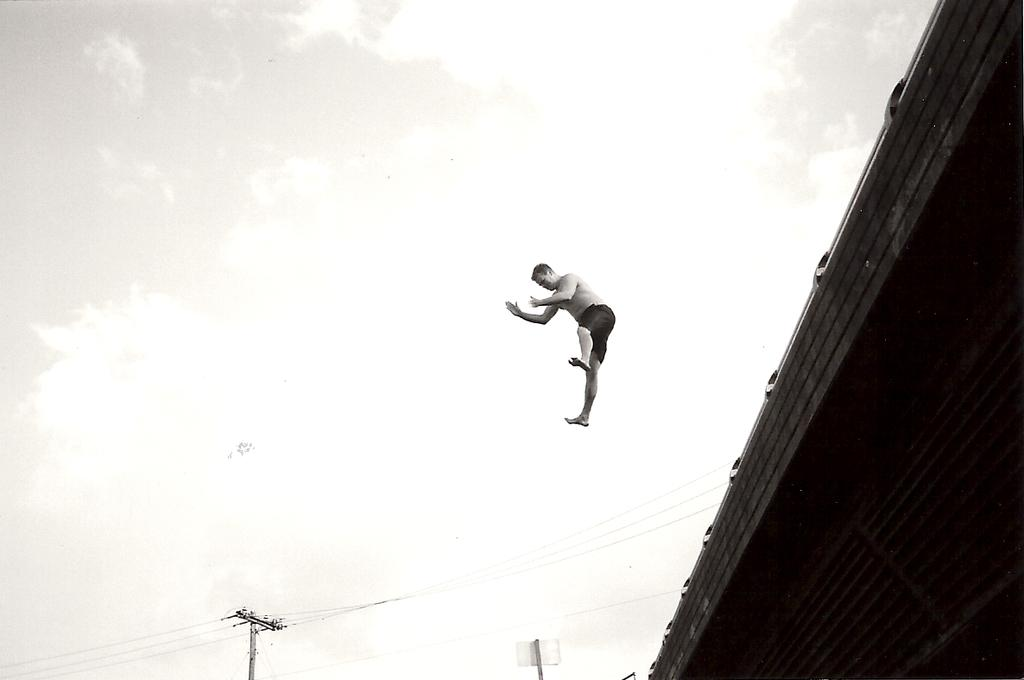What is the person in the image doing? There is a person in the air in the image. What is located near the person? There is a building and a current pole near the person. What can be seen in the background of the image? There are clouds and the sky visible in the background. What type of leaf is being used as a propeller by the person in the image? There is no leaf present in the image, and the person is not using any object as a propeller. 